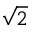Convert formula to latex. <formula><loc_0><loc_0><loc_500><loc_500>\sqrt { 2 }</formula> 